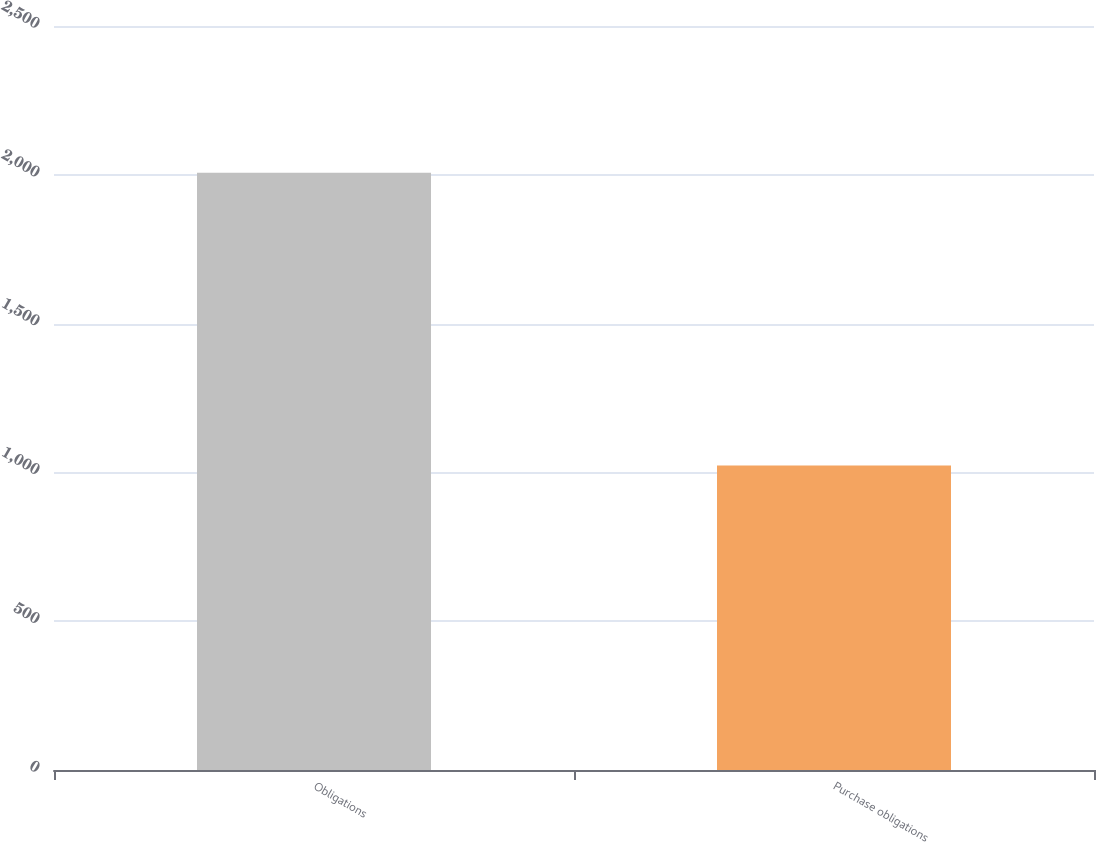<chart> <loc_0><loc_0><loc_500><loc_500><bar_chart><fcel>Obligations<fcel>Purchase obligations<nl><fcel>2007<fcel>1023.5<nl></chart> 